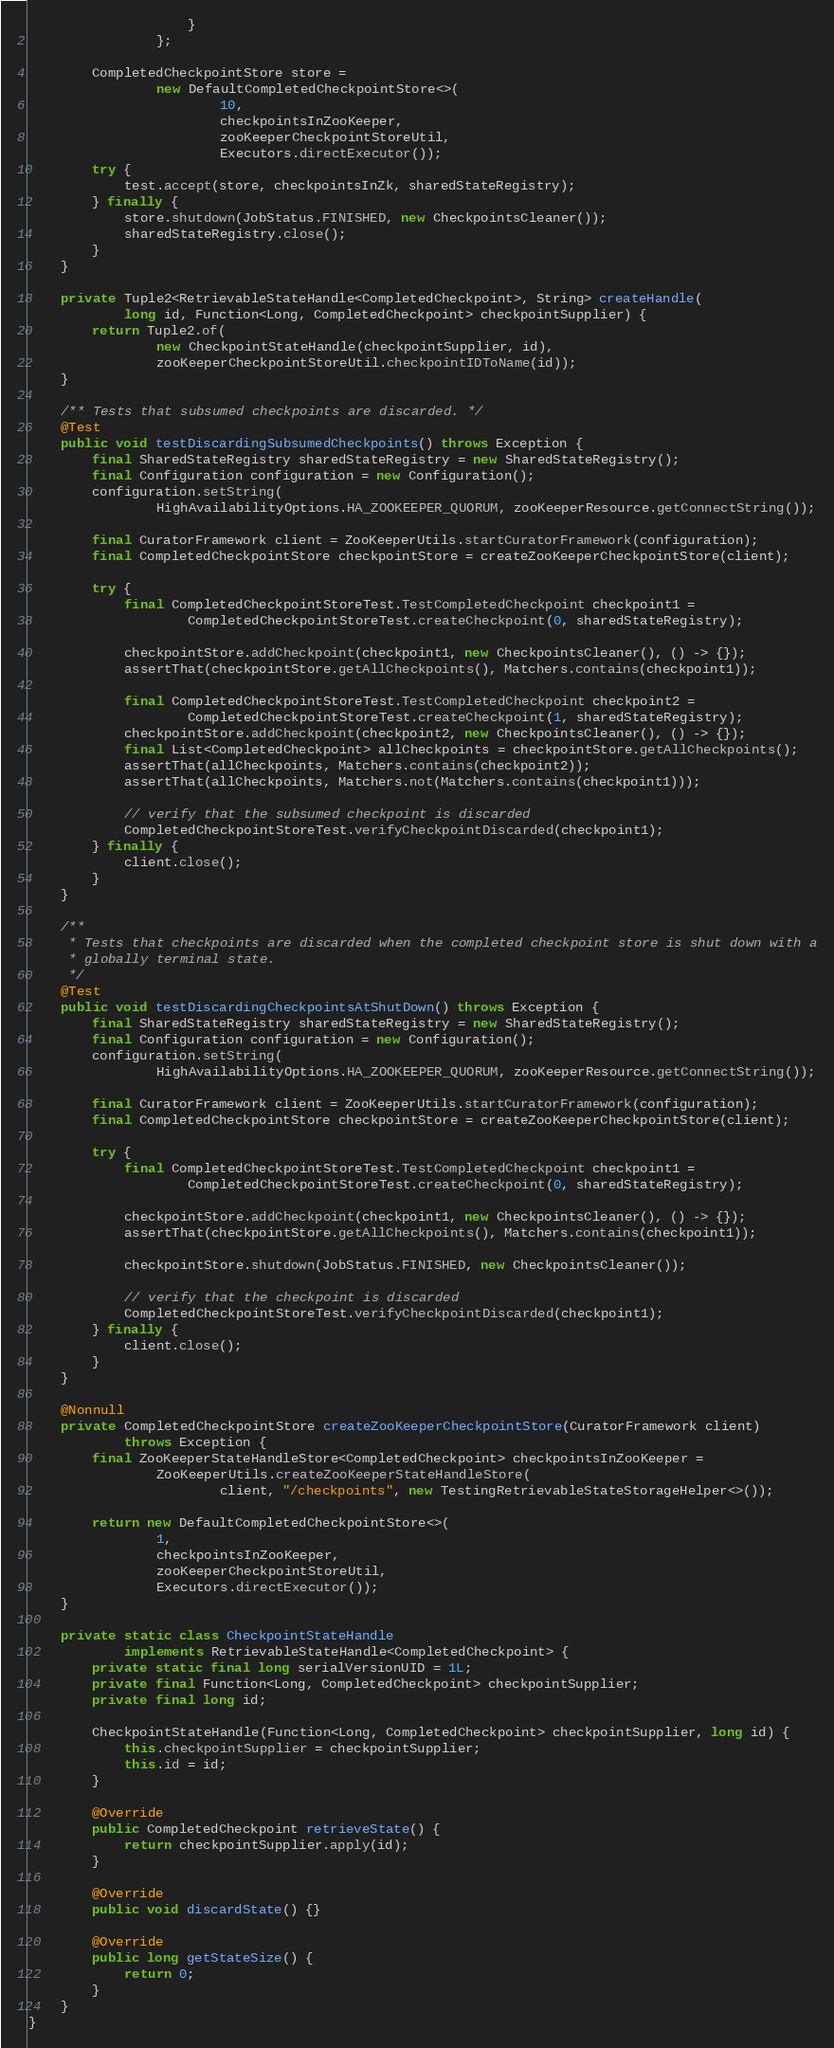Convert code to text. <code><loc_0><loc_0><loc_500><loc_500><_Java_>                    }
                };

        CompletedCheckpointStore store =
                new DefaultCompletedCheckpointStore<>(
                        10,
                        checkpointsInZooKeeper,
                        zooKeeperCheckpointStoreUtil,
                        Executors.directExecutor());
        try {
            test.accept(store, checkpointsInZk, sharedStateRegistry);
        } finally {
            store.shutdown(JobStatus.FINISHED, new CheckpointsCleaner());
            sharedStateRegistry.close();
        }
    }

    private Tuple2<RetrievableStateHandle<CompletedCheckpoint>, String> createHandle(
            long id, Function<Long, CompletedCheckpoint> checkpointSupplier) {
        return Tuple2.of(
                new CheckpointStateHandle(checkpointSupplier, id),
                zooKeeperCheckpointStoreUtil.checkpointIDToName(id));
    }

    /** Tests that subsumed checkpoints are discarded. */
    @Test
    public void testDiscardingSubsumedCheckpoints() throws Exception {
        final SharedStateRegistry sharedStateRegistry = new SharedStateRegistry();
        final Configuration configuration = new Configuration();
        configuration.setString(
                HighAvailabilityOptions.HA_ZOOKEEPER_QUORUM, zooKeeperResource.getConnectString());

        final CuratorFramework client = ZooKeeperUtils.startCuratorFramework(configuration);
        final CompletedCheckpointStore checkpointStore = createZooKeeperCheckpointStore(client);

        try {
            final CompletedCheckpointStoreTest.TestCompletedCheckpoint checkpoint1 =
                    CompletedCheckpointStoreTest.createCheckpoint(0, sharedStateRegistry);

            checkpointStore.addCheckpoint(checkpoint1, new CheckpointsCleaner(), () -> {});
            assertThat(checkpointStore.getAllCheckpoints(), Matchers.contains(checkpoint1));

            final CompletedCheckpointStoreTest.TestCompletedCheckpoint checkpoint2 =
                    CompletedCheckpointStoreTest.createCheckpoint(1, sharedStateRegistry);
            checkpointStore.addCheckpoint(checkpoint2, new CheckpointsCleaner(), () -> {});
            final List<CompletedCheckpoint> allCheckpoints = checkpointStore.getAllCheckpoints();
            assertThat(allCheckpoints, Matchers.contains(checkpoint2));
            assertThat(allCheckpoints, Matchers.not(Matchers.contains(checkpoint1)));

            // verify that the subsumed checkpoint is discarded
            CompletedCheckpointStoreTest.verifyCheckpointDiscarded(checkpoint1);
        } finally {
            client.close();
        }
    }

    /**
     * Tests that checkpoints are discarded when the completed checkpoint store is shut down with a
     * globally terminal state.
     */
    @Test
    public void testDiscardingCheckpointsAtShutDown() throws Exception {
        final SharedStateRegistry sharedStateRegistry = new SharedStateRegistry();
        final Configuration configuration = new Configuration();
        configuration.setString(
                HighAvailabilityOptions.HA_ZOOKEEPER_QUORUM, zooKeeperResource.getConnectString());

        final CuratorFramework client = ZooKeeperUtils.startCuratorFramework(configuration);
        final CompletedCheckpointStore checkpointStore = createZooKeeperCheckpointStore(client);

        try {
            final CompletedCheckpointStoreTest.TestCompletedCheckpoint checkpoint1 =
                    CompletedCheckpointStoreTest.createCheckpoint(0, sharedStateRegistry);

            checkpointStore.addCheckpoint(checkpoint1, new CheckpointsCleaner(), () -> {});
            assertThat(checkpointStore.getAllCheckpoints(), Matchers.contains(checkpoint1));

            checkpointStore.shutdown(JobStatus.FINISHED, new CheckpointsCleaner());

            // verify that the checkpoint is discarded
            CompletedCheckpointStoreTest.verifyCheckpointDiscarded(checkpoint1);
        } finally {
            client.close();
        }
    }

    @Nonnull
    private CompletedCheckpointStore createZooKeeperCheckpointStore(CuratorFramework client)
            throws Exception {
        final ZooKeeperStateHandleStore<CompletedCheckpoint> checkpointsInZooKeeper =
                ZooKeeperUtils.createZooKeeperStateHandleStore(
                        client, "/checkpoints", new TestingRetrievableStateStorageHelper<>());

        return new DefaultCompletedCheckpointStore<>(
                1,
                checkpointsInZooKeeper,
                zooKeeperCheckpointStoreUtil,
                Executors.directExecutor());
    }

    private static class CheckpointStateHandle
            implements RetrievableStateHandle<CompletedCheckpoint> {
        private static final long serialVersionUID = 1L;
        private final Function<Long, CompletedCheckpoint> checkpointSupplier;
        private final long id;

        CheckpointStateHandle(Function<Long, CompletedCheckpoint> checkpointSupplier, long id) {
            this.checkpointSupplier = checkpointSupplier;
            this.id = id;
        }

        @Override
        public CompletedCheckpoint retrieveState() {
            return checkpointSupplier.apply(id);
        }

        @Override
        public void discardState() {}

        @Override
        public long getStateSize() {
            return 0;
        }
    }
}
</code> 